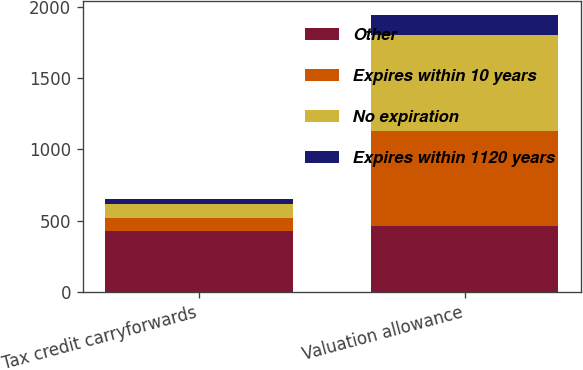Convert chart. <chart><loc_0><loc_0><loc_500><loc_500><stacked_bar_chart><ecel><fcel>Tax credit carryforwards<fcel>Valuation allowance<nl><fcel>Other<fcel>428<fcel>465<nl><fcel>Expires within 10 years<fcel>89<fcel>663<nl><fcel>No expiration<fcel>100<fcel>677<nl><fcel>Expires within 1120 years<fcel>35<fcel>135<nl></chart> 